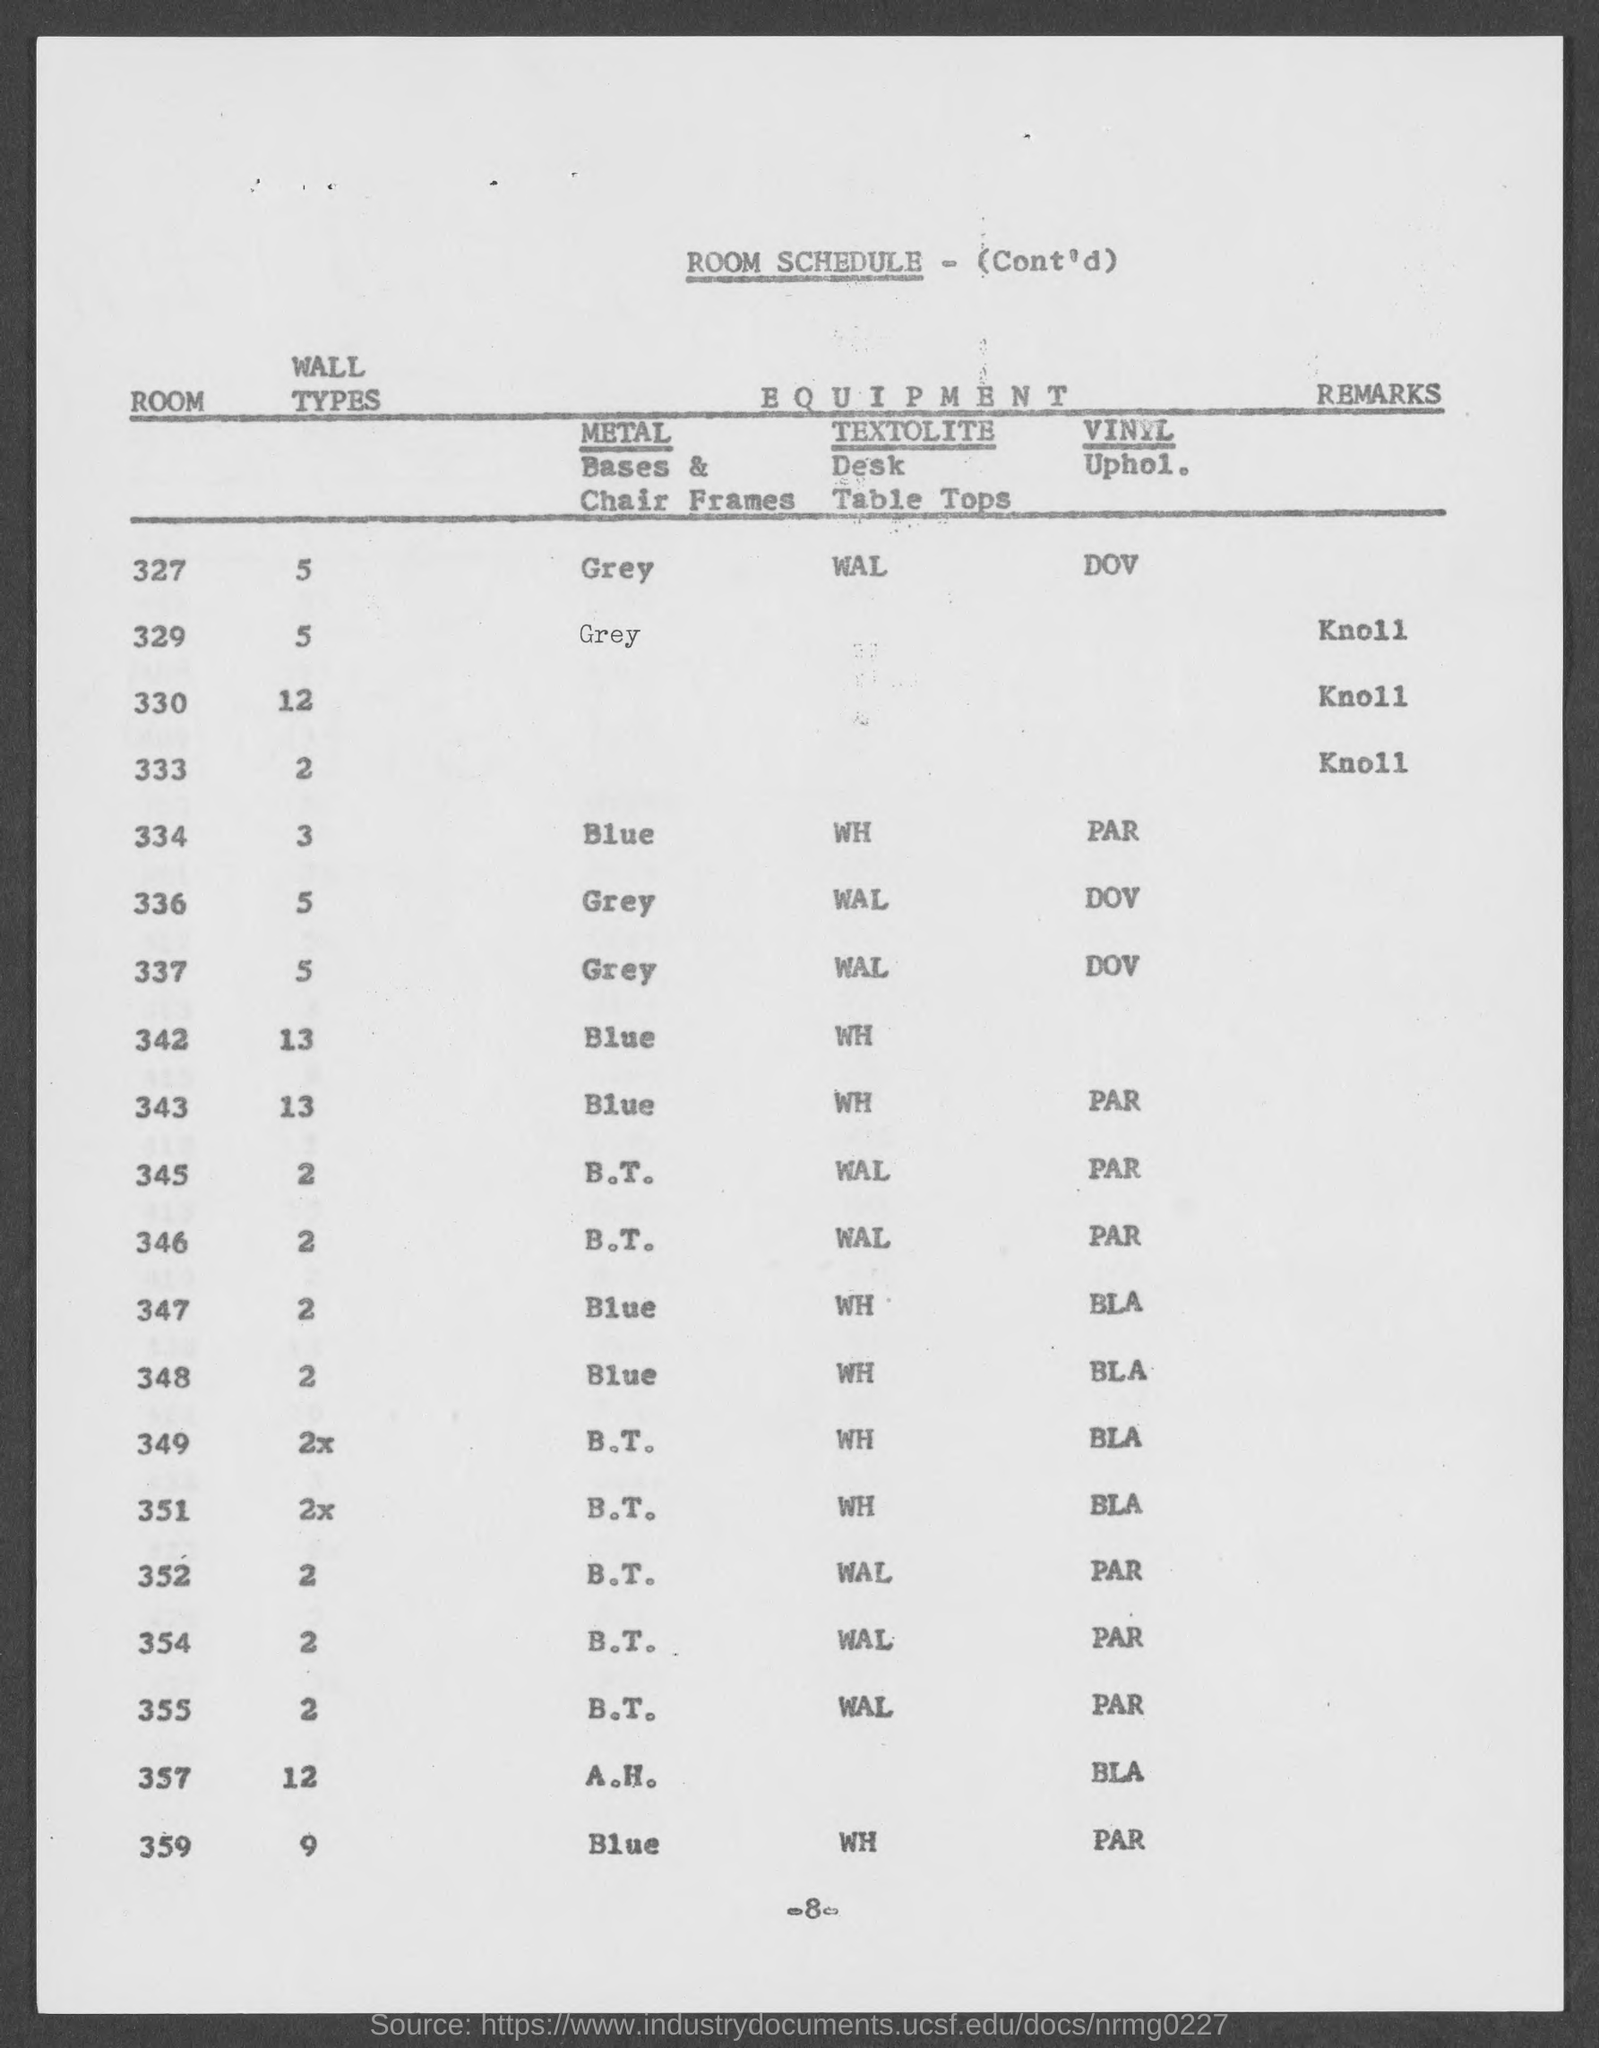Specify some key components in this picture. The wall type for Room 349, as per the room schedule, is 2x.. Room 337 is scheduled to have vinyl upholstery installed, as per the room schedule. The Room 334 is scheduled to have a wall type according to the room schedule. The page number mentioned in this document is 8. The metal bases and chair frames used in Room 334 are blue. 